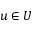Convert formula to latex. <formula><loc_0><loc_0><loc_500><loc_500>u \in U</formula> 